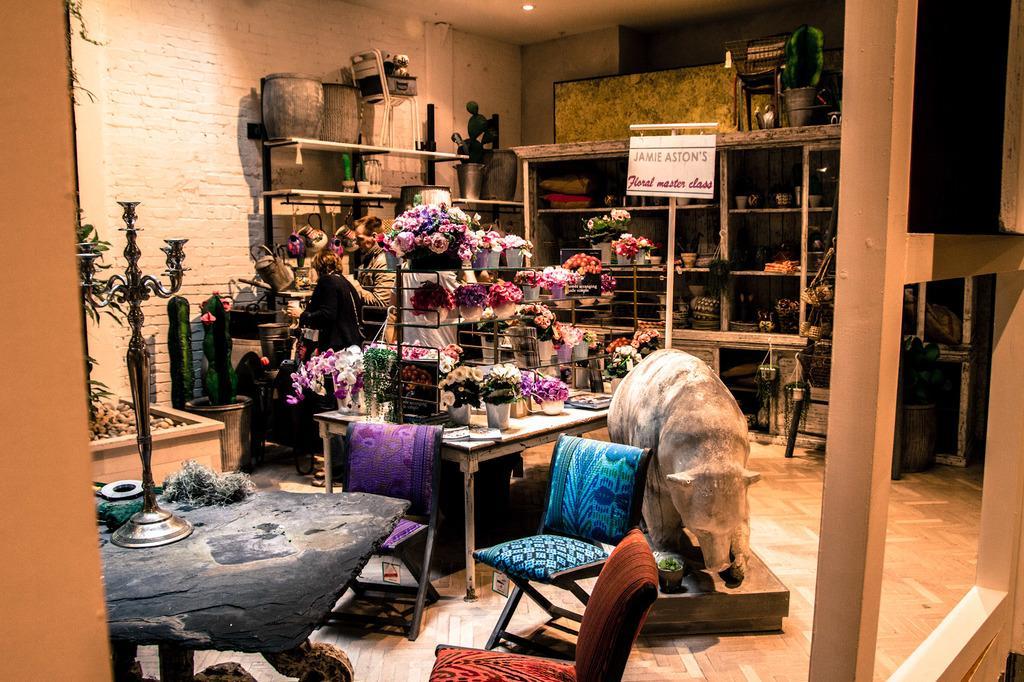Can you describe this image briefly? This is picture is inside the room, there are two persons are standing behind the room. There are flowers pots on the table. There is a sculpture in the middle of the picture. At the top there are lights and there are chairs in the front. 